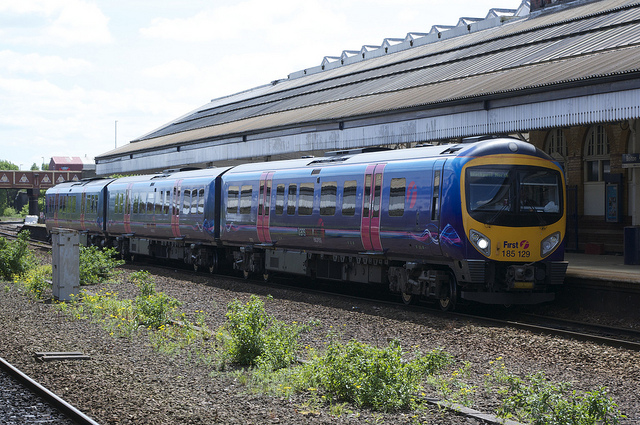<image>Where is the train going? It is unknown where the train is going. It could be going to a station or a depot. Where is the train going? I don't know where the train is going. It can be going forward, to the train station, to New York, east, to the depot, north, or to the station. 